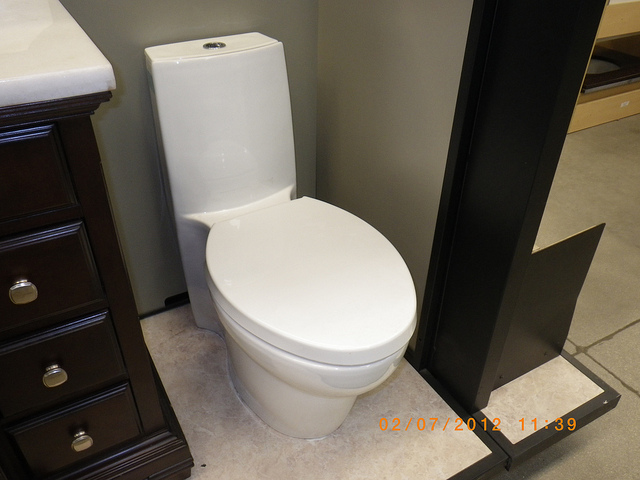Read and extract the text from this image. 02/07/2012 